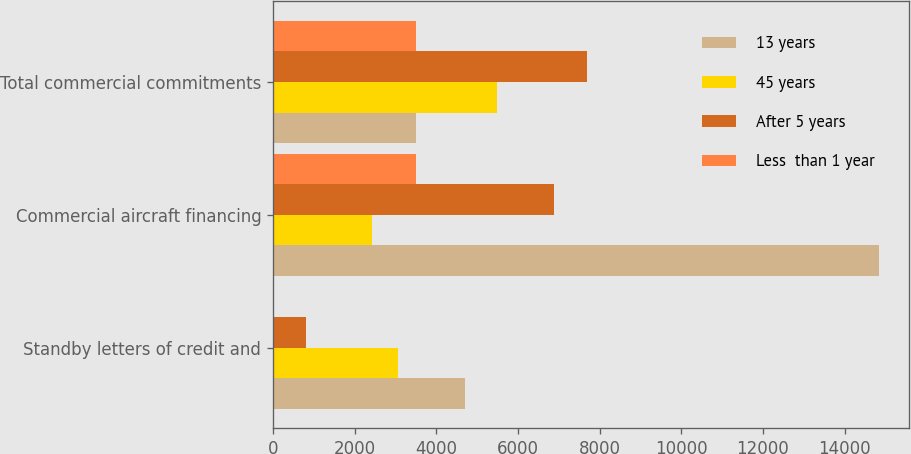<chart> <loc_0><loc_0><loc_500><loc_500><stacked_bar_chart><ecel><fcel>Standby letters of credit and<fcel>Commercial aircraft financing<fcel>Total commercial commitments<nl><fcel>13 years<fcel>4701<fcel>14847<fcel>3496<nl><fcel>45 years<fcel>3051<fcel>2432<fcel>5483<nl><fcel>After 5 years<fcel>805<fcel>6874<fcel>7679<nl><fcel>Less  than 1 year<fcel>3<fcel>3493<fcel>3496<nl></chart> 